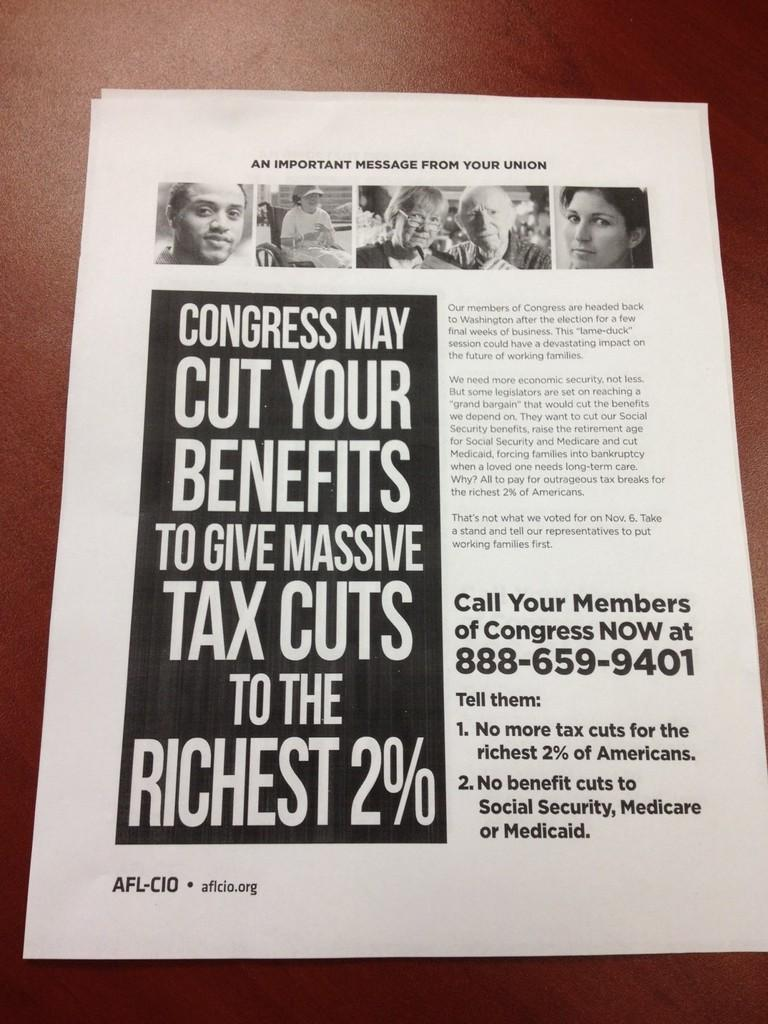<image>
Relay a brief, clear account of the picture shown. A flyer warns about the Congress and tax cuts to the rich. 